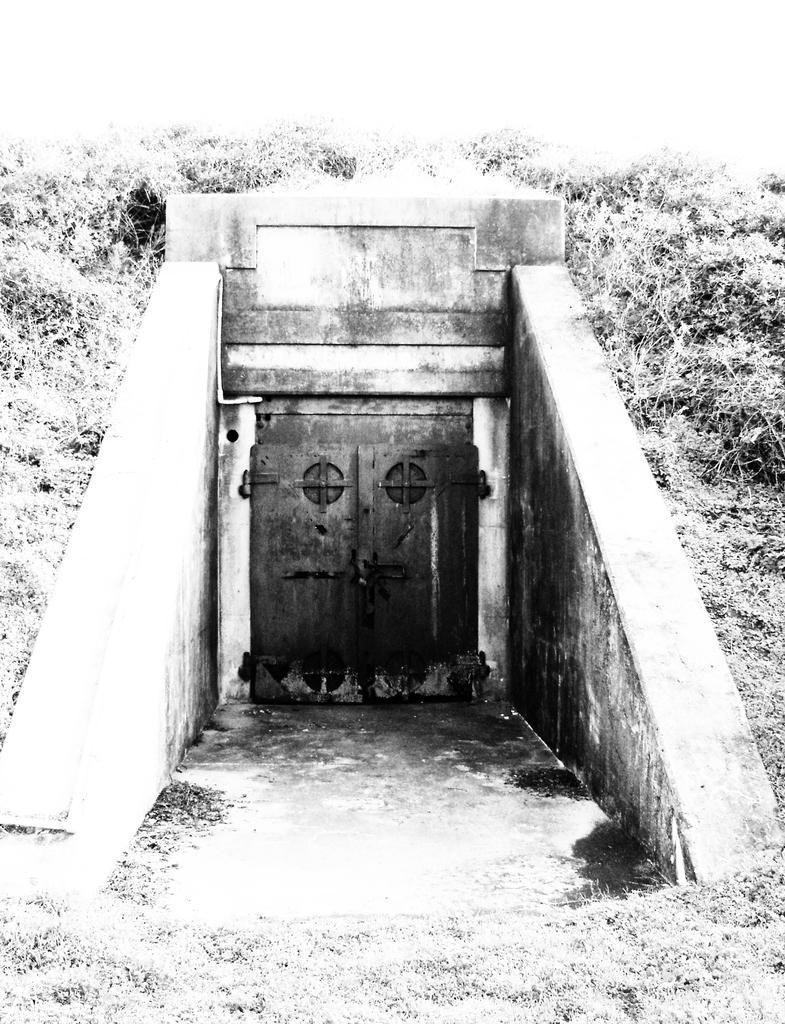Describe this image in one or two sentences. In this image I can see a door, left and right I can see trees and grass, and the image is in black and white. 